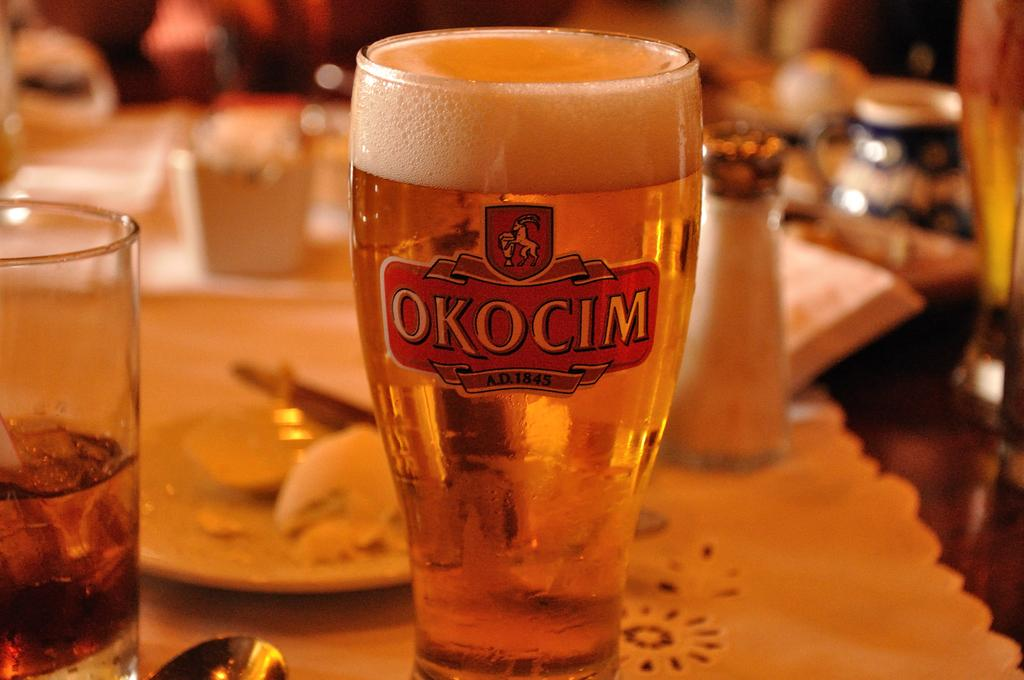What type of glass is visible in the image? There is a beer glass in the image. What else can be seen on the table or surface in the image? There are food items on a plate in the image. What type of picture is hanging on the wall in the image? There is no mention of a picture or a wall in the image; it only features a beer glass and food items on a plate. 